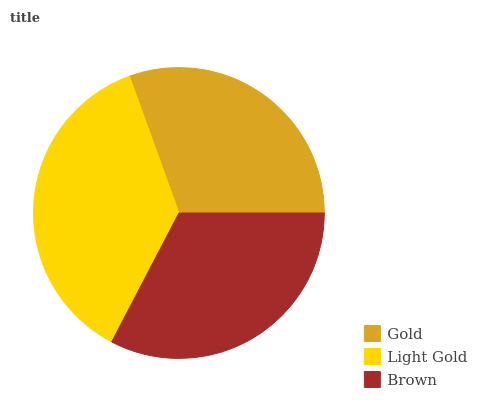Is Gold the minimum?
Answer yes or no. Yes. Is Light Gold the maximum?
Answer yes or no. Yes. Is Brown the minimum?
Answer yes or no. No. Is Brown the maximum?
Answer yes or no. No. Is Light Gold greater than Brown?
Answer yes or no. Yes. Is Brown less than Light Gold?
Answer yes or no. Yes. Is Brown greater than Light Gold?
Answer yes or no. No. Is Light Gold less than Brown?
Answer yes or no. No. Is Brown the high median?
Answer yes or no. Yes. Is Brown the low median?
Answer yes or no. Yes. Is Gold the high median?
Answer yes or no. No. Is Light Gold the low median?
Answer yes or no. No. 